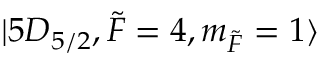Convert formula to latex. <formula><loc_0><loc_0><loc_500><loc_500>| 5 D _ { 5 / 2 } , \tilde { F } = 4 , m _ { \tilde { F } } = 1 \rangle</formula> 